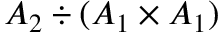Convert formula to latex. <formula><loc_0><loc_0><loc_500><loc_500>A _ { 2 } \div ( A _ { 1 } \times A _ { 1 } )</formula> 